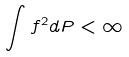Convert formula to latex. <formula><loc_0><loc_0><loc_500><loc_500>\int f ^ { 2 } d P < \infty</formula> 